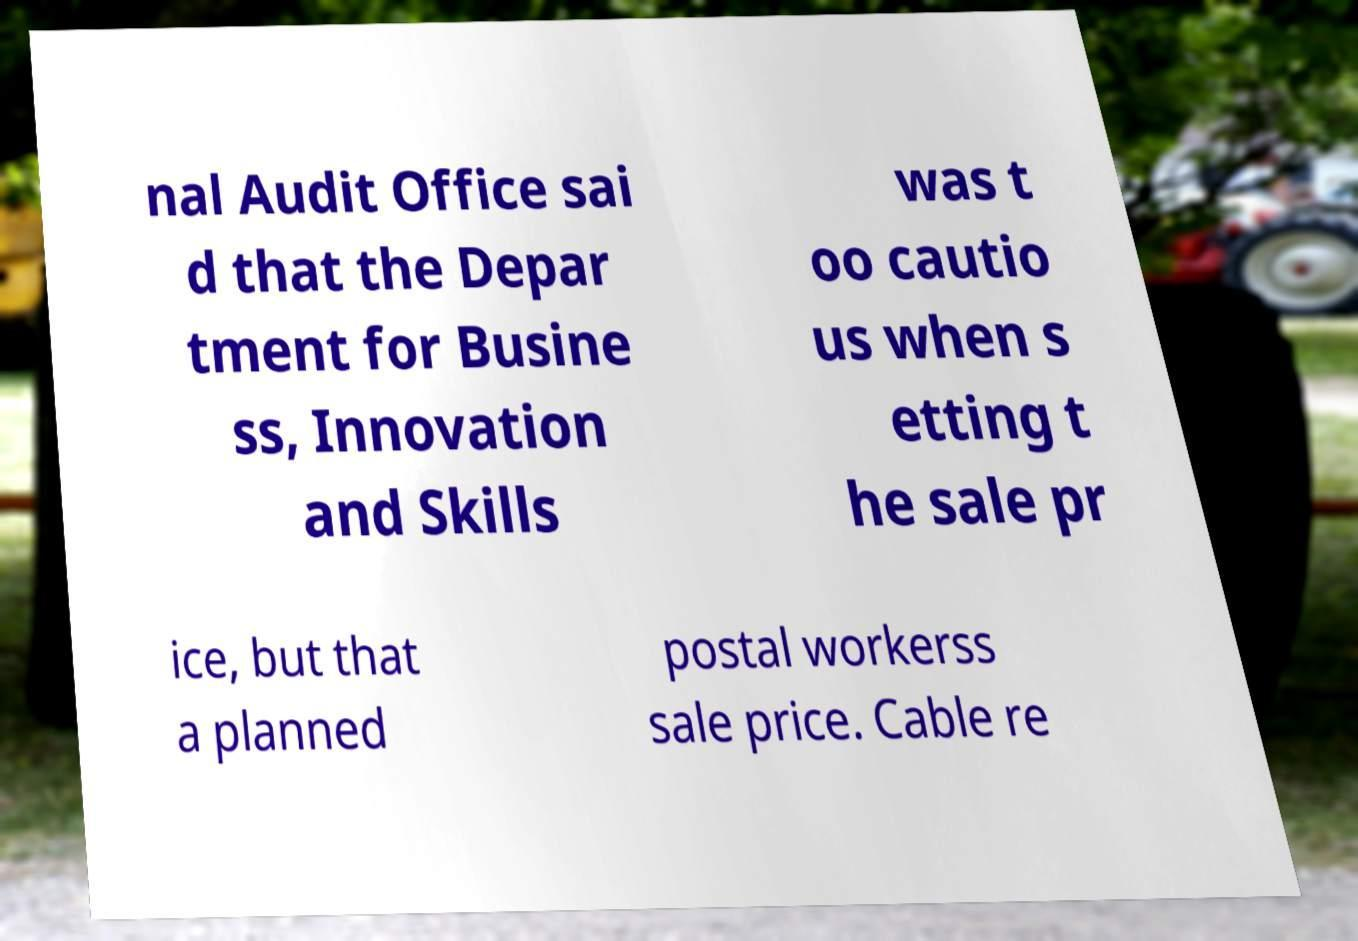Please read and relay the text visible in this image. What does it say? nal Audit Office sai d that the Depar tment for Busine ss, Innovation and Skills was t oo cautio us when s etting t he sale pr ice, but that a planned postal workerss sale price. Cable re 